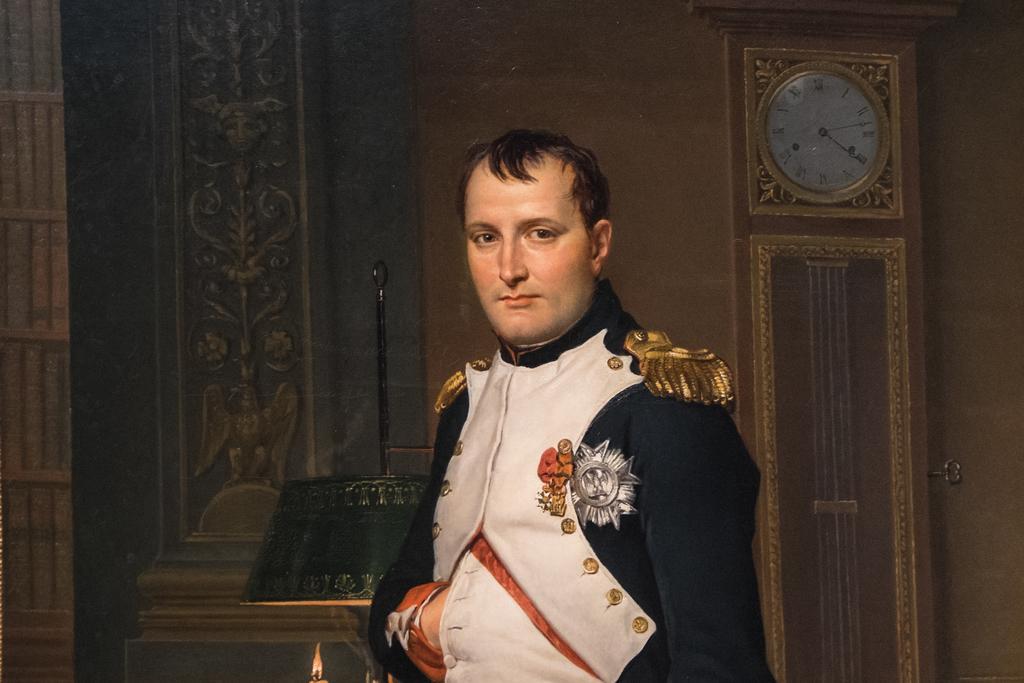Please provide a concise description of this image. In this image I can see a person. In the background, I can see a clock on the wall. 